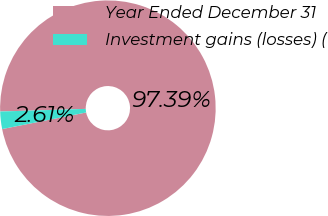Convert chart. <chart><loc_0><loc_0><loc_500><loc_500><pie_chart><fcel>Year Ended December 31<fcel>Investment gains (losses) (<nl><fcel>97.39%<fcel>2.61%<nl></chart> 